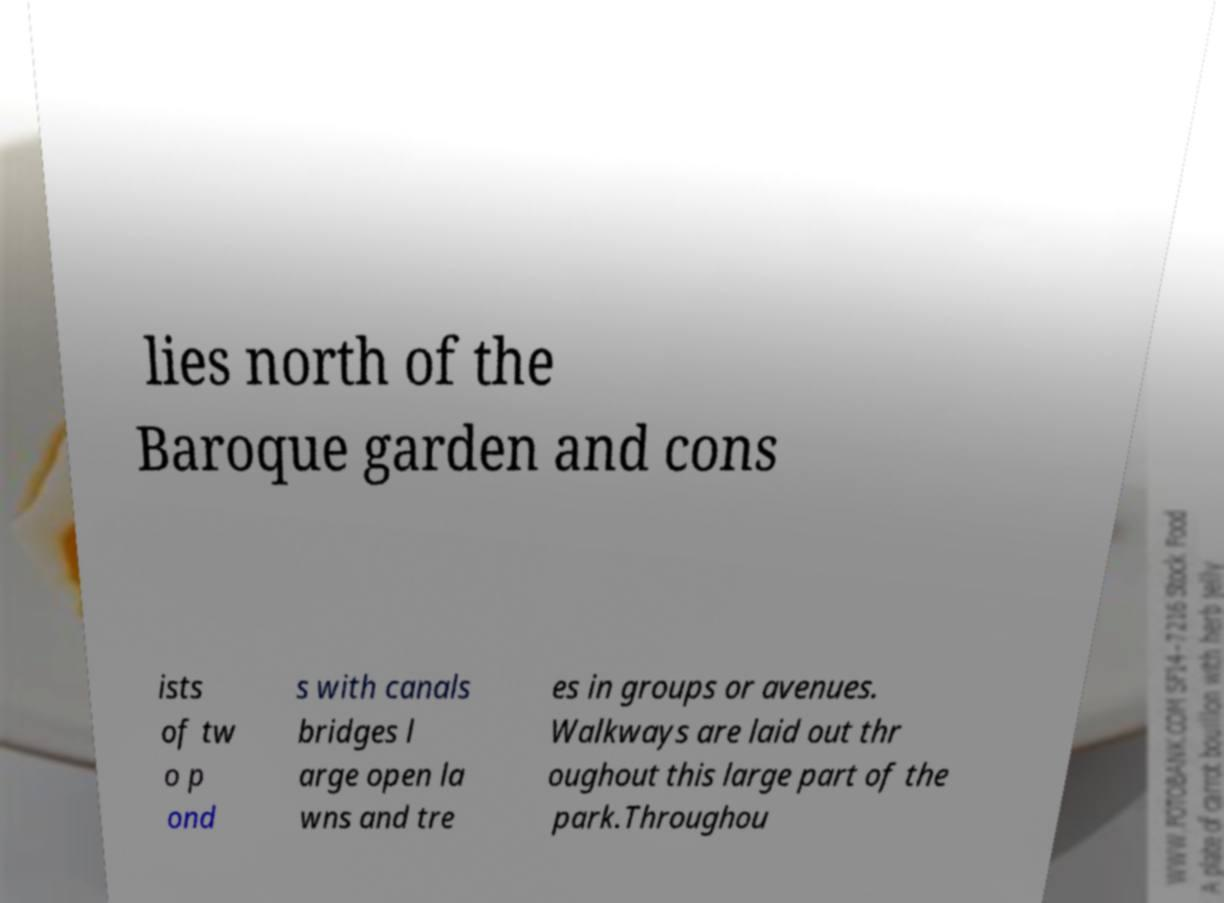Please identify and transcribe the text found in this image. lies north of the Baroque garden and cons ists of tw o p ond s with canals bridges l arge open la wns and tre es in groups or avenues. Walkways are laid out thr oughout this large part of the park.Throughou 